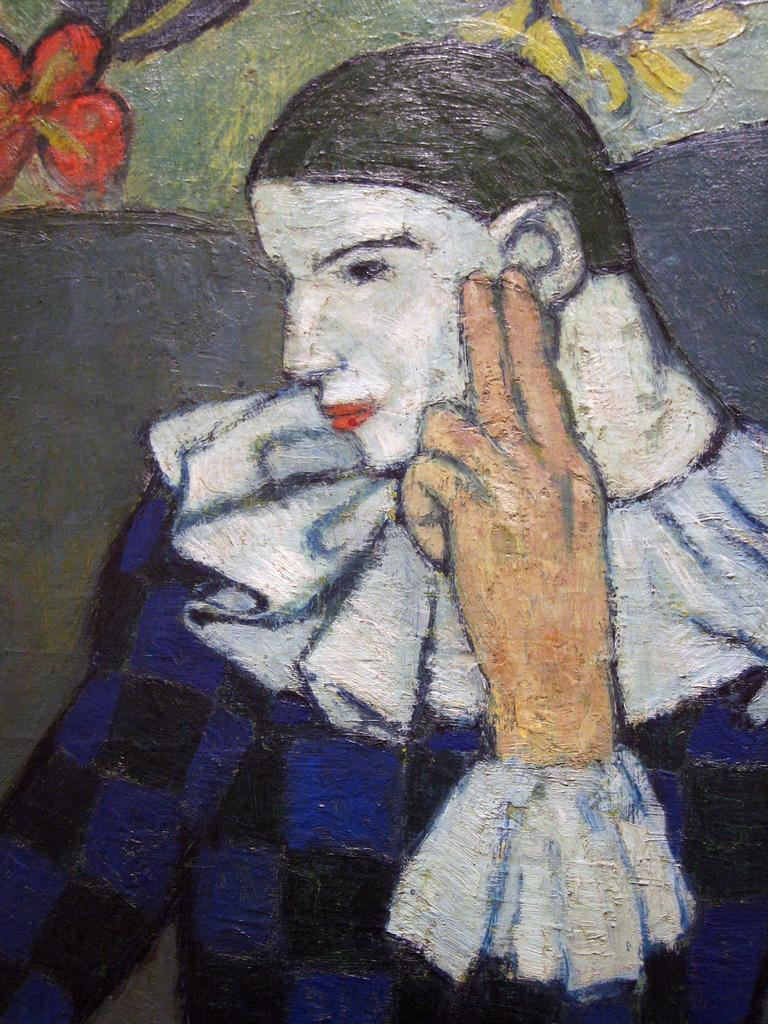What is the main subject of the image? There is a painting in the image. What does the painting depict? The painting depicts a person. What type of poison is being used by the person in the painting? There is no poison or any indication of poison in the image; the painting depicts a person without any additional context. 